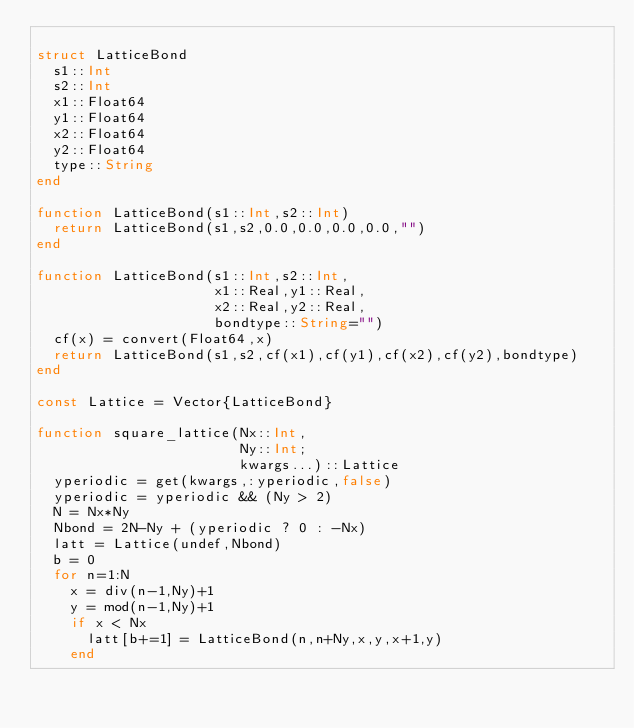<code> <loc_0><loc_0><loc_500><loc_500><_Julia_>
struct LatticeBond
  s1::Int
  s2::Int
  x1::Float64
  y1::Float64
  x2::Float64
  y2::Float64
  type::String
end

function LatticeBond(s1::Int,s2::Int)
  return LatticeBond(s1,s2,0.0,0.0,0.0,0.0,"")
end

function LatticeBond(s1::Int,s2::Int,
                     x1::Real,y1::Real,
                     x2::Real,y2::Real,
                     bondtype::String="")
  cf(x) = convert(Float64,x)
  return LatticeBond(s1,s2,cf(x1),cf(y1),cf(x2),cf(y2),bondtype)
end

const Lattice = Vector{LatticeBond}

function square_lattice(Nx::Int,
                        Ny::Int;
                        kwargs...)::Lattice
  yperiodic = get(kwargs,:yperiodic,false)
  yperiodic = yperiodic && (Ny > 2)
  N = Nx*Ny
  Nbond = 2N-Ny + (yperiodic ? 0 : -Nx)
  latt = Lattice(undef,Nbond)
  b = 0
  for n=1:N
    x = div(n-1,Ny)+1
    y = mod(n-1,Ny)+1
    if x < Nx
      latt[b+=1] = LatticeBond(n,n+Ny,x,y,x+1,y)
    end</code> 